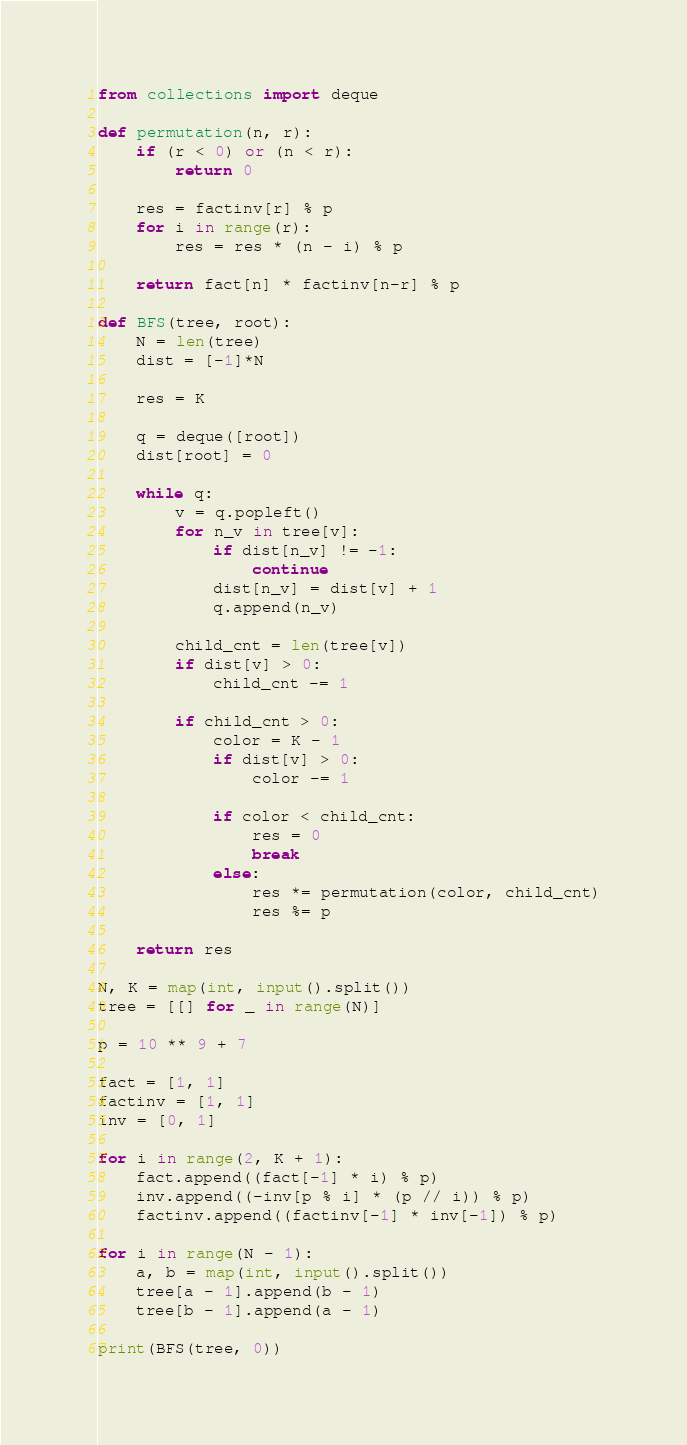<code> <loc_0><loc_0><loc_500><loc_500><_Python_>from collections import deque

def permutation(n, r):
    if (r < 0) or (n < r):
        return 0

    res = factinv[r] % p
    for i in range(r):
        res = res * (n - i) % p

    return fact[n] * factinv[n-r] % p

def BFS(tree, root):
    N = len(tree)
    dist = [-1]*N

    res = K

    q = deque([root])
    dist[root] = 0

    while q:
        v = q.popleft()
        for n_v in tree[v]:
            if dist[n_v] != -1:
                continue
            dist[n_v] = dist[v] + 1
            q.append(n_v)
        
        child_cnt = len(tree[v])
        if dist[v] > 0:
            child_cnt -= 1

        if child_cnt > 0:
            color = K - 1
            if dist[v] > 0:
                color -= 1
            
            if color < child_cnt:
                res = 0
                break
            else:
                res *= permutation(color, child_cnt)
                res %= p
    
    return res

N, K = map(int, input().split())
tree = [[] for _ in range(N)]

p = 10 ** 9 + 7

fact = [1, 1]
factinv = [1, 1]
inv = [0, 1]
 
for i in range(2, K + 1):
    fact.append((fact[-1] * i) % p)
    inv.append((-inv[p % i] * (p // i)) % p)
    factinv.append((factinv[-1] * inv[-1]) % p)

for i in range(N - 1):
    a, b = map(int, input().split())
    tree[a - 1].append(b - 1)
    tree[b - 1].append(a - 1)

print(BFS(tree, 0))</code> 